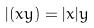Convert formula to latex. <formula><loc_0><loc_0><loc_500><loc_500>| ( x y ) = | x | y</formula> 